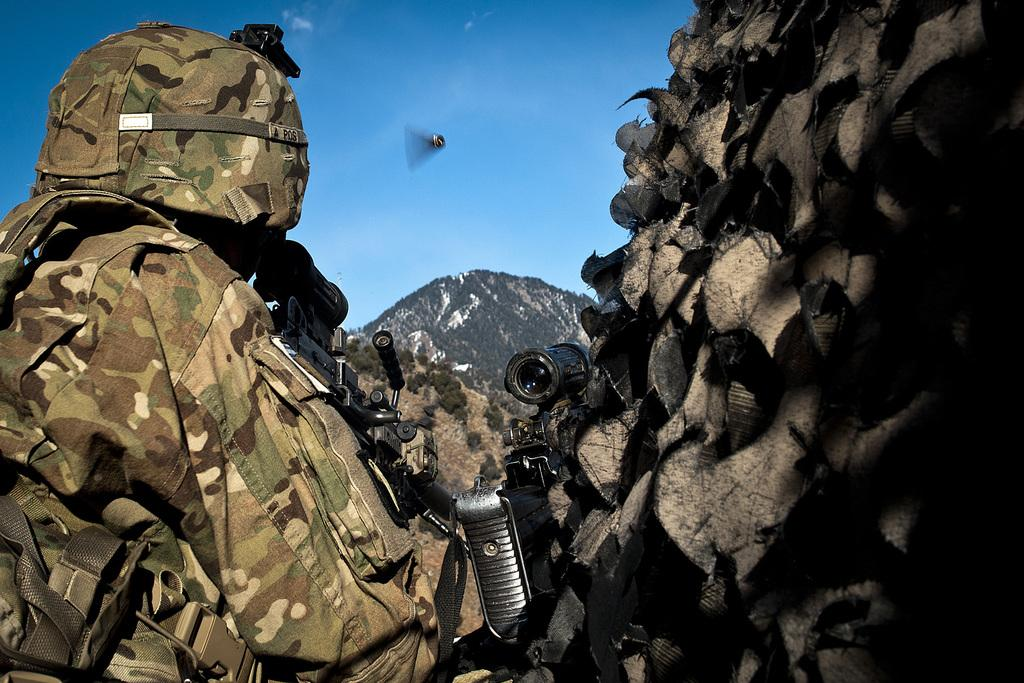What type of clothing is featured in the image? There is a military dress in the image. What objects are associated with the military dress? There are guns in the image. What can be seen in the background of the image? There are plants and mountains in the background of the image. What color is the sky in the image? The sky is blue in the image. Where is the drain located in the image? There is no drain present in the image. What type of beverage is being served in the image? The image does not show any beverages, including eggnog. 